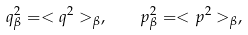Convert formula to latex. <formula><loc_0><loc_0><loc_500><loc_500>q _ { \beta } ^ { 2 } = < q ^ { 2 } > _ { \beta } , \quad p _ { \beta } ^ { 2 } = < p ^ { 2 } > _ { \beta } ,</formula> 